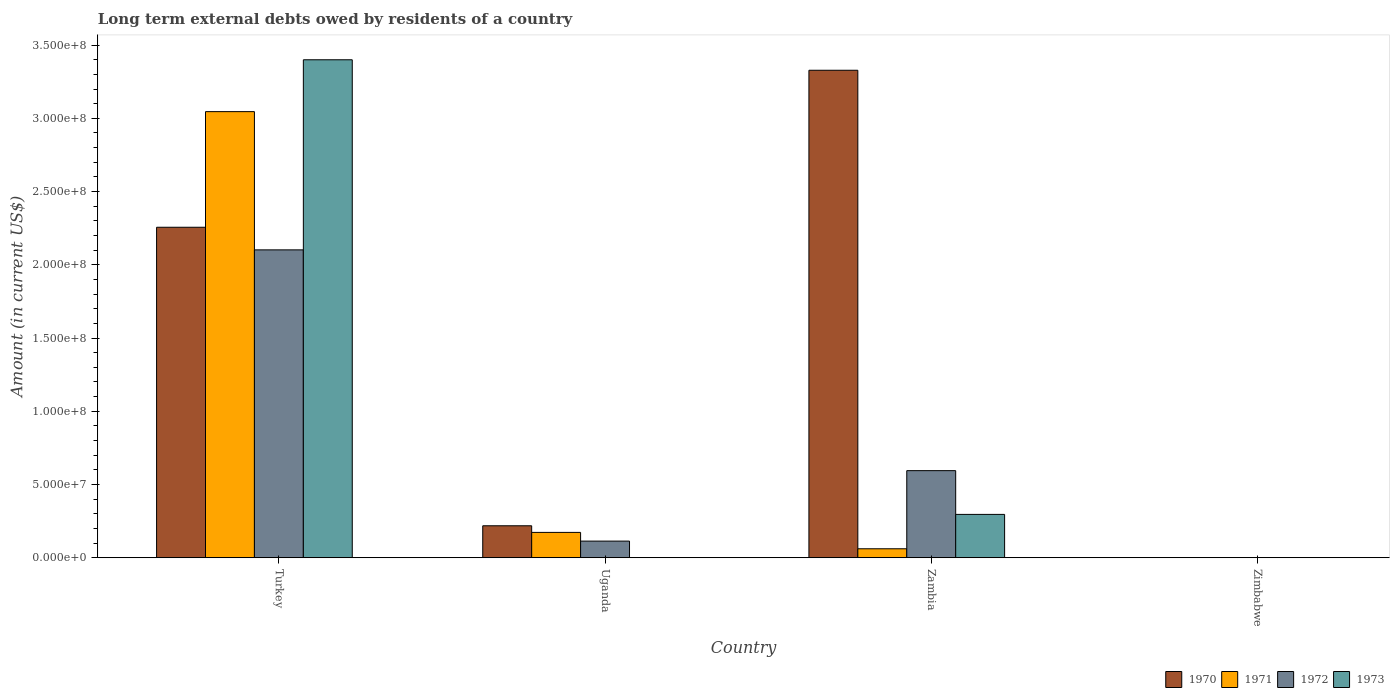How many different coloured bars are there?
Offer a very short reply. 4. Are the number of bars per tick equal to the number of legend labels?
Provide a succinct answer. No. Are the number of bars on each tick of the X-axis equal?
Ensure brevity in your answer.  No. What is the label of the 3rd group of bars from the left?
Your response must be concise. Zambia. What is the amount of long-term external debts owed by residents in 1972 in Zimbabwe?
Offer a terse response. 0. Across all countries, what is the maximum amount of long-term external debts owed by residents in 1972?
Provide a short and direct response. 2.10e+08. Across all countries, what is the minimum amount of long-term external debts owed by residents in 1971?
Provide a succinct answer. 0. In which country was the amount of long-term external debts owed by residents in 1970 maximum?
Ensure brevity in your answer.  Zambia. What is the total amount of long-term external debts owed by residents in 1973 in the graph?
Give a very brief answer. 3.70e+08. What is the difference between the amount of long-term external debts owed by residents in 1972 in Turkey and that in Uganda?
Your answer should be very brief. 1.99e+08. What is the difference between the amount of long-term external debts owed by residents in 1972 in Turkey and the amount of long-term external debts owed by residents in 1970 in Zambia?
Keep it short and to the point. -1.23e+08. What is the average amount of long-term external debts owed by residents in 1971 per country?
Provide a short and direct response. 8.20e+07. What is the difference between the amount of long-term external debts owed by residents of/in 1973 and amount of long-term external debts owed by residents of/in 1971 in Turkey?
Your answer should be compact. 3.54e+07. What is the ratio of the amount of long-term external debts owed by residents in 1973 in Turkey to that in Zambia?
Keep it short and to the point. 11.49. What is the difference between the highest and the second highest amount of long-term external debts owed by residents in 1972?
Your answer should be very brief. 1.51e+08. What is the difference between the highest and the lowest amount of long-term external debts owed by residents in 1971?
Make the answer very short. 3.05e+08. Is it the case that in every country, the sum of the amount of long-term external debts owed by residents in 1973 and amount of long-term external debts owed by residents in 1972 is greater than the amount of long-term external debts owed by residents in 1971?
Your response must be concise. No. How many bars are there?
Your response must be concise. 11. How many countries are there in the graph?
Provide a succinct answer. 4. Does the graph contain grids?
Provide a short and direct response. No. Where does the legend appear in the graph?
Give a very brief answer. Bottom right. What is the title of the graph?
Ensure brevity in your answer.  Long term external debts owed by residents of a country. What is the label or title of the X-axis?
Your response must be concise. Country. What is the label or title of the Y-axis?
Keep it short and to the point. Amount (in current US$). What is the Amount (in current US$) of 1970 in Turkey?
Keep it short and to the point. 2.26e+08. What is the Amount (in current US$) of 1971 in Turkey?
Offer a very short reply. 3.05e+08. What is the Amount (in current US$) in 1972 in Turkey?
Your answer should be very brief. 2.10e+08. What is the Amount (in current US$) in 1973 in Turkey?
Keep it short and to the point. 3.40e+08. What is the Amount (in current US$) of 1970 in Uganda?
Provide a short and direct response. 2.18e+07. What is the Amount (in current US$) in 1971 in Uganda?
Your answer should be very brief. 1.73e+07. What is the Amount (in current US$) of 1972 in Uganda?
Offer a very short reply. 1.14e+07. What is the Amount (in current US$) of 1970 in Zambia?
Offer a terse response. 3.33e+08. What is the Amount (in current US$) of 1971 in Zambia?
Provide a short and direct response. 6.13e+06. What is the Amount (in current US$) in 1972 in Zambia?
Make the answer very short. 5.95e+07. What is the Amount (in current US$) in 1973 in Zambia?
Your answer should be very brief. 2.96e+07. What is the Amount (in current US$) in 1973 in Zimbabwe?
Provide a succinct answer. 0. Across all countries, what is the maximum Amount (in current US$) in 1970?
Offer a very short reply. 3.33e+08. Across all countries, what is the maximum Amount (in current US$) of 1971?
Offer a terse response. 3.05e+08. Across all countries, what is the maximum Amount (in current US$) of 1972?
Your answer should be very brief. 2.10e+08. Across all countries, what is the maximum Amount (in current US$) of 1973?
Make the answer very short. 3.40e+08. Across all countries, what is the minimum Amount (in current US$) of 1971?
Provide a succinct answer. 0. Across all countries, what is the minimum Amount (in current US$) of 1973?
Provide a succinct answer. 0. What is the total Amount (in current US$) in 1970 in the graph?
Your answer should be compact. 5.80e+08. What is the total Amount (in current US$) in 1971 in the graph?
Ensure brevity in your answer.  3.28e+08. What is the total Amount (in current US$) of 1972 in the graph?
Offer a very short reply. 2.81e+08. What is the total Amount (in current US$) of 1973 in the graph?
Make the answer very short. 3.70e+08. What is the difference between the Amount (in current US$) of 1970 in Turkey and that in Uganda?
Offer a terse response. 2.04e+08. What is the difference between the Amount (in current US$) in 1971 in Turkey and that in Uganda?
Your response must be concise. 2.87e+08. What is the difference between the Amount (in current US$) in 1972 in Turkey and that in Uganda?
Your response must be concise. 1.99e+08. What is the difference between the Amount (in current US$) of 1970 in Turkey and that in Zambia?
Keep it short and to the point. -1.07e+08. What is the difference between the Amount (in current US$) of 1971 in Turkey and that in Zambia?
Your response must be concise. 2.98e+08. What is the difference between the Amount (in current US$) of 1972 in Turkey and that in Zambia?
Your answer should be very brief. 1.51e+08. What is the difference between the Amount (in current US$) of 1973 in Turkey and that in Zambia?
Give a very brief answer. 3.10e+08. What is the difference between the Amount (in current US$) of 1970 in Uganda and that in Zambia?
Provide a succinct answer. -3.11e+08. What is the difference between the Amount (in current US$) of 1971 in Uganda and that in Zambia?
Make the answer very short. 1.12e+07. What is the difference between the Amount (in current US$) of 1972 in Uganda and that in Zambia?
Provide a succinct answer. -4.81e+07. What is the difference between the Amount (in current US$) in 1970 in Turkey and the Amount (in current US$) in 1971 in Uganda?
Give a very brief answer. 2.08e+08. What is the difference between the Amount (in current US$) of 1970 in Turkey and the Amount (in current US$) of 1972 in Uganda?
Make the answer very short. 2.14e+08. What is the difference between the Amount (in current US$) of 1971 in Turkey and the Amount (in current US$) of 1972 in Uganda?
Keep it short and to the point. 2.93e+08. What is the difference between the Amount (in current US$) in 1970 in Turkey and the Amount (in current US$) in 1971 in Zambia?
Your answer should be compact. 2.19e+08. What is the difference between the Amount (in current US$) of 1970 in Turkey and the Amount (in current US$) of 1972 in Zambia?
Provide a short and direct response. 1.66e+08. What is the difference between the Amount (in current US$) in 1970 in Turkey and the Amount (in current US$) in 1973 in Zambia?
Your answer should be compact. 1.96e+08. What is the difference between the Amount (in current US$) of 1971 in Turkey and the Amount (in current US$) of 1972 in Zambia?
Give a very brief answer. 2.45e+08. What is the difference between the Amount (in current US$) in 1971 in Turkey and the Amount (in current US$) in 1973 in Zambia?
Your answer should be compact. 2.75e+08. What is the difference between the Amount (in current US$) in 1972 in Turkey and the Amount (in current US$) in 1973 in Zambia?
Provide a succinct answer. 1.81e+08. What is the difference between the Amount (in current US$) of 1970 in Uganda and the Amount (in current US$) of 1971 in Zambia?
Make the answer very short. 1.57e+07. What is the difference between the Amount (in current US$) in 1970 in Uganda and the Amount (in current US$) in 1972 in Zambia?
Your response must be concise. -3.76e+07. What is the difference between the Amount (in current US$) of 1970 in Uganda and the Amount (in current US$) of 1973 in Zambia?
Your answer should be very brief. -7.76e+06. What is the difference between the Amount (in current US$) in 1971 in Uganda and the Amount (in current US$) in 1972 in Zambia?
Ensure brevity in your answer.  -4.22e+07. What is the difference between the Amount (in current US$) in 1971 in Uganda and the Amount (in current US$) in 1973 in Zambia?
Your response must be concise. -1.23e+07. What is the difference between the Amount (in current US$) in 1972 in Uganda and the Amount (in current US$) in 1973 in Zambia?
Offer a very short reply. -1.82e+07. What is the average Amount (in current US$) in 1970 per country?
Ensure brevity in your answer.  1.45e+08. What is the average Amount (in current US$) in 1971 per country?
Give a very brief answer. 8.20e+07. What is the average Amount (in current US$) in 1972 per country?
Ensure brevity in your answer.  7.03e+07. What is the average Amount (in current US$) of 1973 per country?
Offer a terse response. 9.24e+07. What is the difference between the Amount (in current US$) in 1970 and Amount (in current US$) in 1971 in Turkey?
Provide a short and direct response. -7.89e+07. What is the difference between the Amount (in current US$) of 1970 and Amount (in current US$) of 1972 in Turkey?
Offer a terse response. 1.54e+07. What is the difference between the Amount (in current US$) in 1970 and Amount (in current US$) in 1973 in Turkey?
Provide a succinct answer. -1.14e+08. What is the difference between the Amount (in current US$) of 1971 and Amount (in current US$) of 1972 in Turkey?
Ensure brevity in your answer.  9.44e+07. What is the difference between the Amount (in current US$) of 1971 and Amount (in current US$) of 1973 in Turkey?
Keep it short and to the point. -3.54e+07. What is the difference between the Amount (in current US$) of 1972 and Amount (in current US$) of 1973 in Turkey?
Keep it short and to the point. -1.30e+08. What is the difference between the Amount (in current US$) of 1970 and Amount (in current US$) of 1971 in Uganda?
Keep it short and to the point. 4.52e+06. What is the difference between the Amount (in current US$) in 1970 and Amount (in current US$) in 1972 in Uganda?
Give a very brief answer. 1.05e+07. What is the difference between the Amount (in current US$) in 1971 and Amount (in current US$) in 1972 in Uganda?
Keep it short and to the point. 5.94e+06. What is the difference between the Amount (in current US$) in 1970 and Amount (in current US$) in 1971 in Zambia?
Keep it short and to the point. 3.27e+08. What is the difference between the Amount (in current US$) of 1970 and Amount (in current US$) of 1972 in Zambia?
Offer a terse response. 2.73e+08. What is the difference between the Amount (in current US$) of 1970 and Amount (in current US$) of 1973 in Zambia?
Your response must be concise. 3.03e+08. What is the difference between the Amount (in current US$) in 1971 and Amount (in current US$) in 1972 in Zambia?
Ensure brevity in your answer.  -5.33e+07. What is the difference between the Amount (in current US$) in 1971 and Amount (in current US$) in 1973 in Zambia?
Your answer should be compact. -2.35e+07. What is the difference between the Amount (in current US$) in 1972 and Amount (in current US$) in 1973 in Zambia?
Give a very brief answer. 2.99e+07. What is the ratio of the Amount (in current US$) in 1970 in Turkey to that in Uganda?
Give a very brief answer. 10.34. What is the ratio of the Amount (in current US$) of 1971 in Turkey to that in Uganda?
Your answer should be compact. 17.6. What is the ratio of the Amount (in current US$) in 1972 in Turkey to that in Uganda?
Give a very brief answer. 18.49. What is the ratio of the Amount (in current US$) of 1970 in Turkey to that in Zambia?
Your response must be concise. 0.68. What is the ratio of the Amount (in current US$) of 1971 in Turkey to that in Zambia?
Your response must be concise. 49.68. What is the ratio of the Amount (in current US$) of 1972 in Turkey to that in Zambia?
Give a very brief answer. 3.53. What is the ratio of the Amount (in current US$) in 1973 in Turkey to that in Zambia?
Keep it short and to the point. 11.49. What is the ratio of the Amount (in current US$) of 1970 in Uganda to that in Zambia?
Offer a very short reply. 0.07. What is the ratio of the Amount (in current US$) of 1971 in Uganda to that in Zambia?
Make the answer very short. 2.82. What is the ratio of the Amount (in current US$) in 1972 in Uganda to that in Zambia?
Provide a short and direct response. 0.19. What is the difference between the highest and the second highest Amount (in current US$) of 1970?
Your answer should be very brief. 1.07e+08. What is the difference between the highest and the second highest Amount (in current US$) in 1971?
Offer a terse response. 2.87e+08. What is the difference between the highest and the second highest Amount (in current US$) in 1972?
Keep it short and to the point. 1.51e+08. What is the difference between the highest and the lowest Amount (in current US$) in 1970?
Make the answer very short. 3.33e+08. What is the difference between the highest and the lowest Amount (in current US$) of 1971?
Provide a succinct answer. 3.05e+08. What is the difference between the highest and the lowest Amount (in current US$) in 1972?
Offer a terse response. 2.10e+08. What is the difference between the highest and the lowest Amount (in current US$) of 1973?
Your answer should be compact. 3.40e+08. 